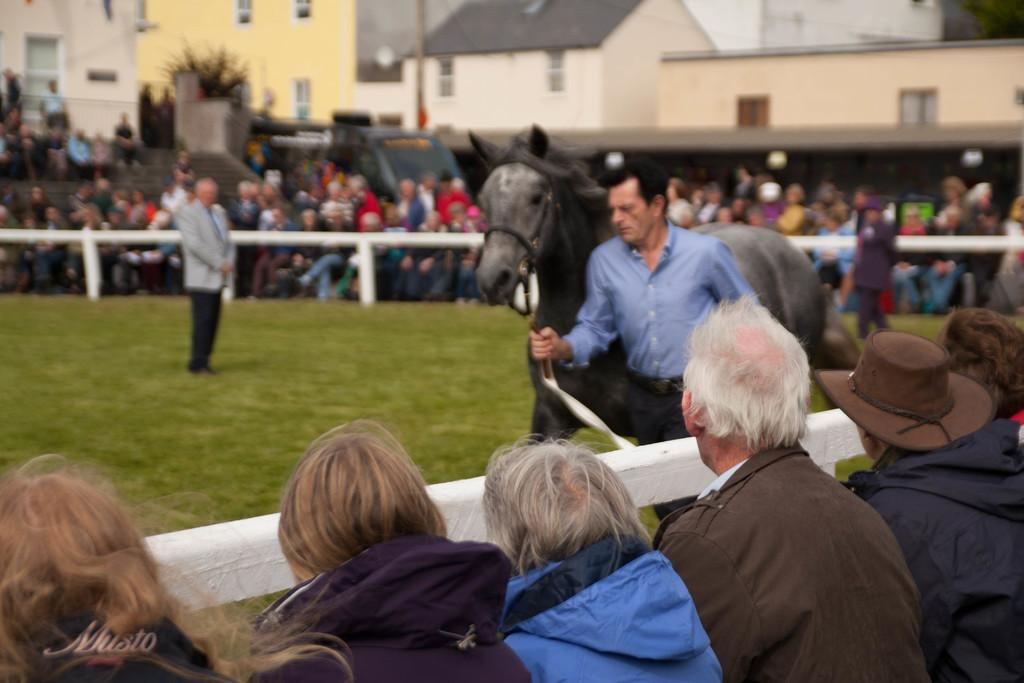What is the person in the image wearing? The person is wearing a blue shirt in the image. What is the person holding in the image? The person is holding a rope in the image. What is the rope connected to? The rope is tightened to a horse in the image. Who is observing the person and the horse in the image? There is a group of audience in the image. What type of structures can be seen in the background of the image? There are houses visible in the image. What type of egg is being used to navigate the system in the image? There is no egg or system present in the image; it features a person, a rope, a horse, an audience, and houses in the background. 